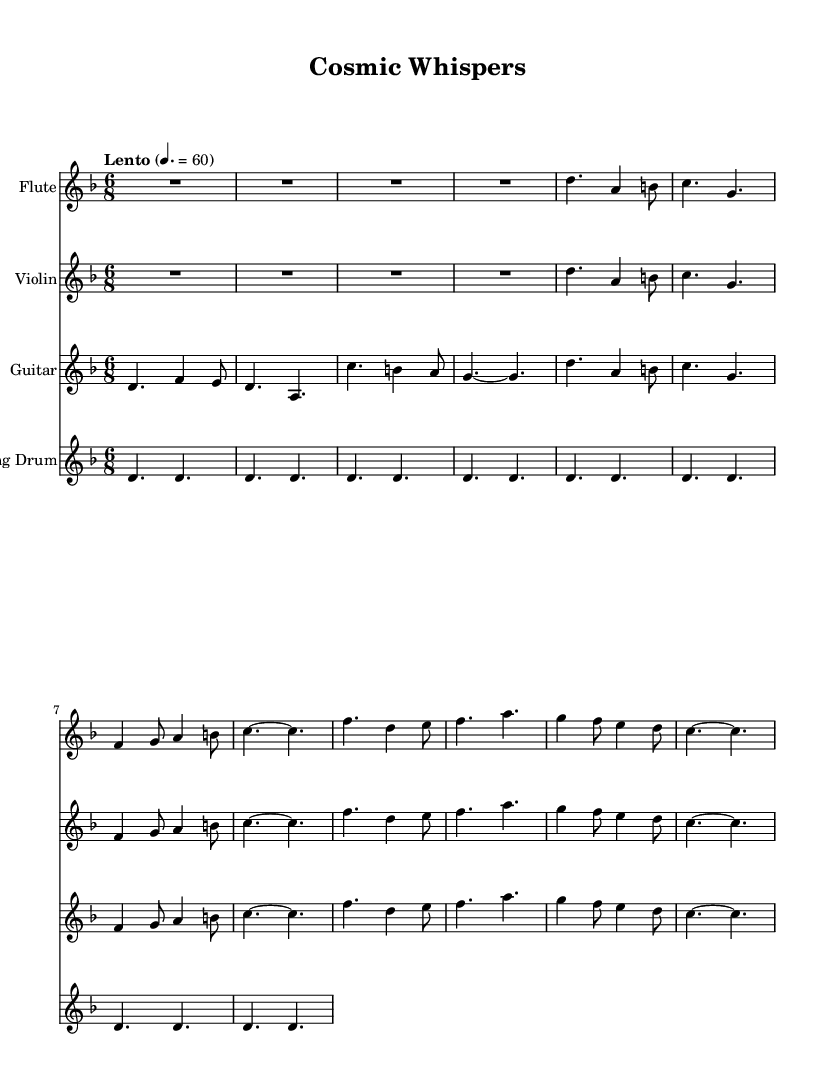What is the key signature of this music? The key signature is D minor, which has one flat (B flat). This can be identified by looking at the key signature indicated at the beginning of the staff.
Answer: D minor What is the time signature of the piece? The time signature is 6/8, which means there are six eighth notes per measure. This is found notated at the beginning of the score.
Answer: 6/8 What is the tempo marking for this piece? The tempo marking is "Lento" with a marking of 60 BPM (beats per minute). This is noted in the tempo section at the start of the score.
Answer: Lento How many measures are in the flute part? The flute part consists of 8 measures. Counting the measures visually from the notation in the staff gives this total.
Answer: 8 What notes are played in the first measure of the guitar? The first measure of the guitar part has the notes D and F. This can be determined by observing the pitch notations within the first measure of the guitar staff.
Answer: D, F Which instruments have the same melodic line in the first section? The flute and violin have the same melodic line in the first section as they share the same sequence of notes and rhythm in their first few measures.
Answer: Flute, Violin What is the rhythmic feel of the piece based on the time signature? The piece has a compound feel with a dotted eighth note followed by a sixteenth note pattern, reflecting the 6/8 time signature which typically gives a lilting, flowing feel. This is obvious from the rhythm structure used throughout the measures.
Answer: Compound 